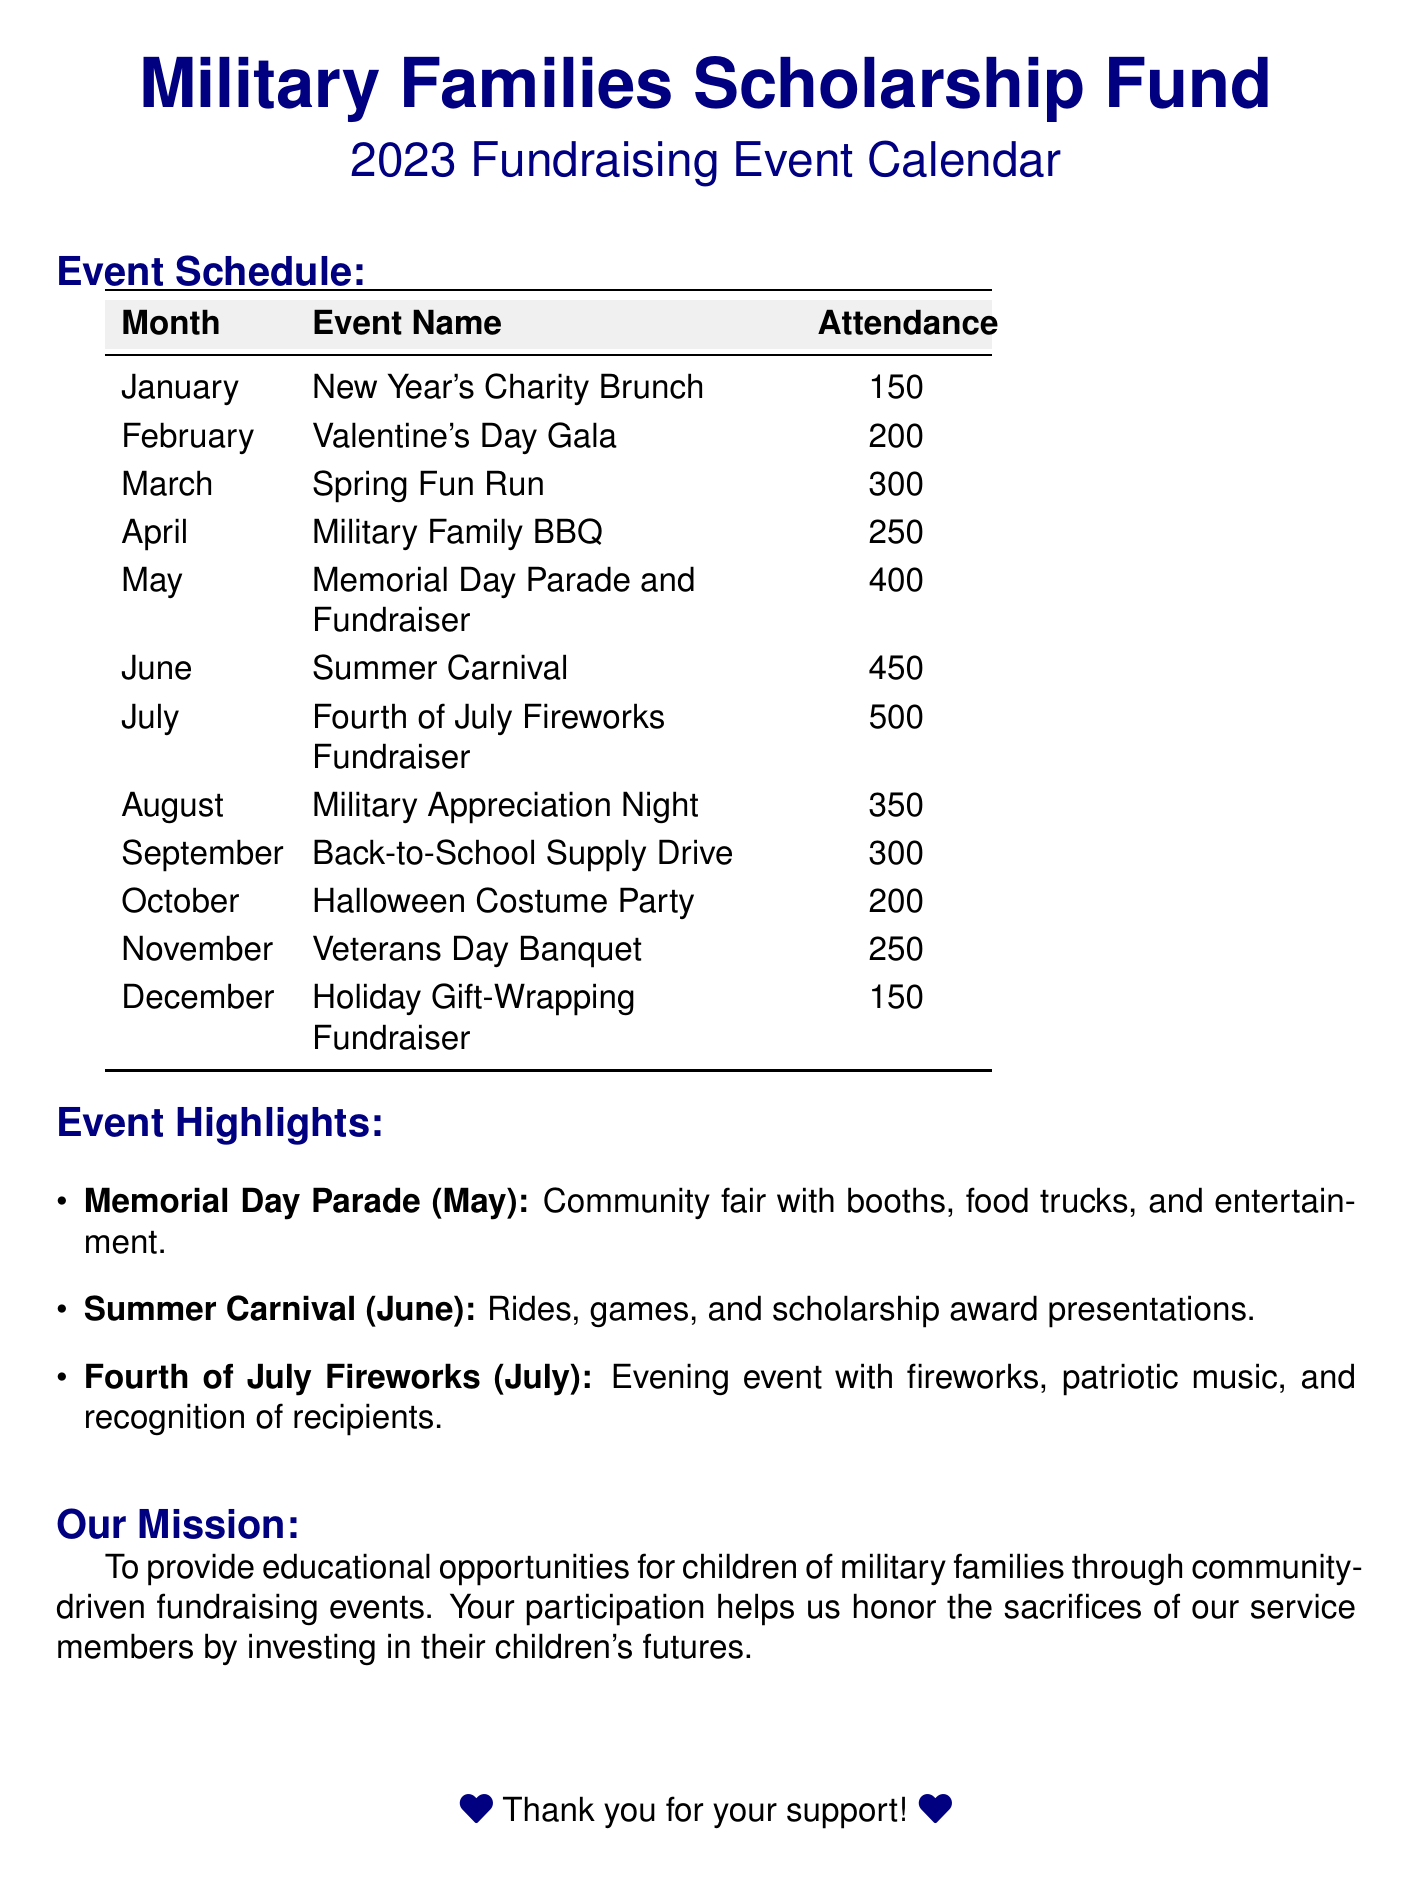What is the name of the event in July? The name of the event is listed in the event schedule for July.
Answer: Fourth of July Fireworks Fundraiser How many attendees are expected for the Memorial Day Parade in May? The expected attendance for the Memorial Day Parade is provided in the table under May.
Answer: 400 What type of event is scheduled for October? The type of event is detailed in the event schedule for October.
Answer: Halloween Costume Party Which month features the Summer Carnival? The month for the Summer Carnival is indicated in the event schedule.
Answer: June What is the expected attendance for the Valentine's Day Gala? The expected attendance is specified in the event schedule for February.
Answer: 200 What are the event highlights listed in the document? The document provides specific events that have highlights mentioned.
Answer: Memorial Day Parade, Summer Carnival, Fourth of July Fireworks How many events are planned for the month of August? The number of events for August can be determined from the event schedule.
Answer: 1 What is the mission of the Military Families Scholarship Fund? The mission statement is clearly articulated in the document.
Answer: To provide educational opportunities for children of military families Which event takes place in September? The specific event in September is mentioned in the event schedule.
Answer: Back-to-School Supply Drive 